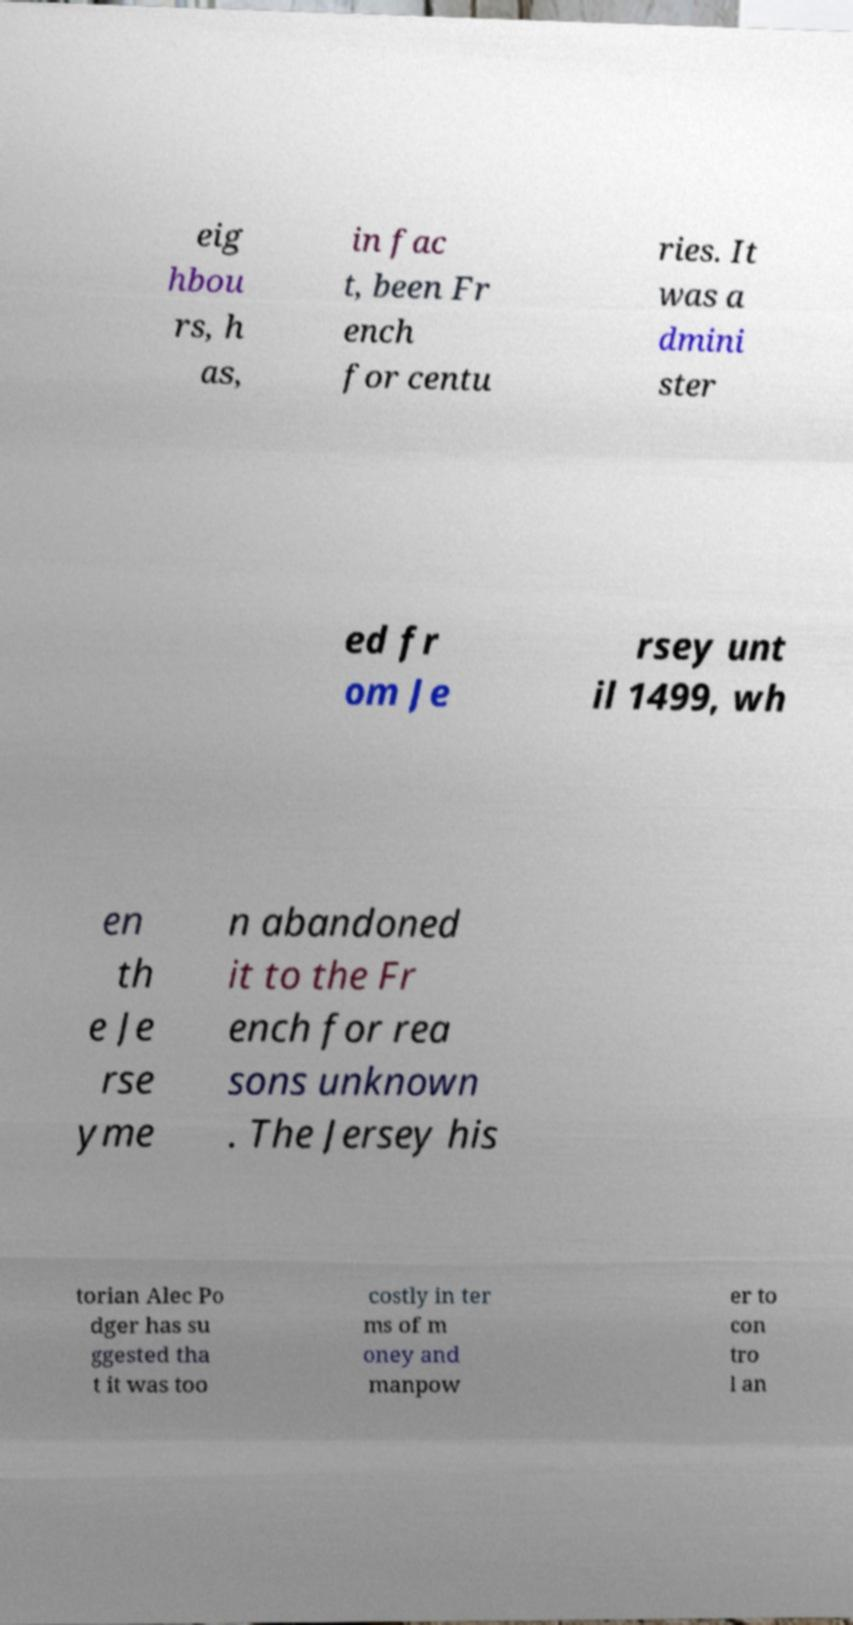For documentation purposes, I need the text within this image transcribed. Could you provide that? eig hbou rs, h as, in fac t, been Fr ench for centu ries. It was a dmini ster ed fr om Je rsey unt il 1499, wh en th e Je rse yme n abandoned it to the Fr ench for rea sons unknown . The Jersey his torian Alec Po dger has su ggested tha t it was too costly in ter ms of m oney and manpow er to con tro l an 